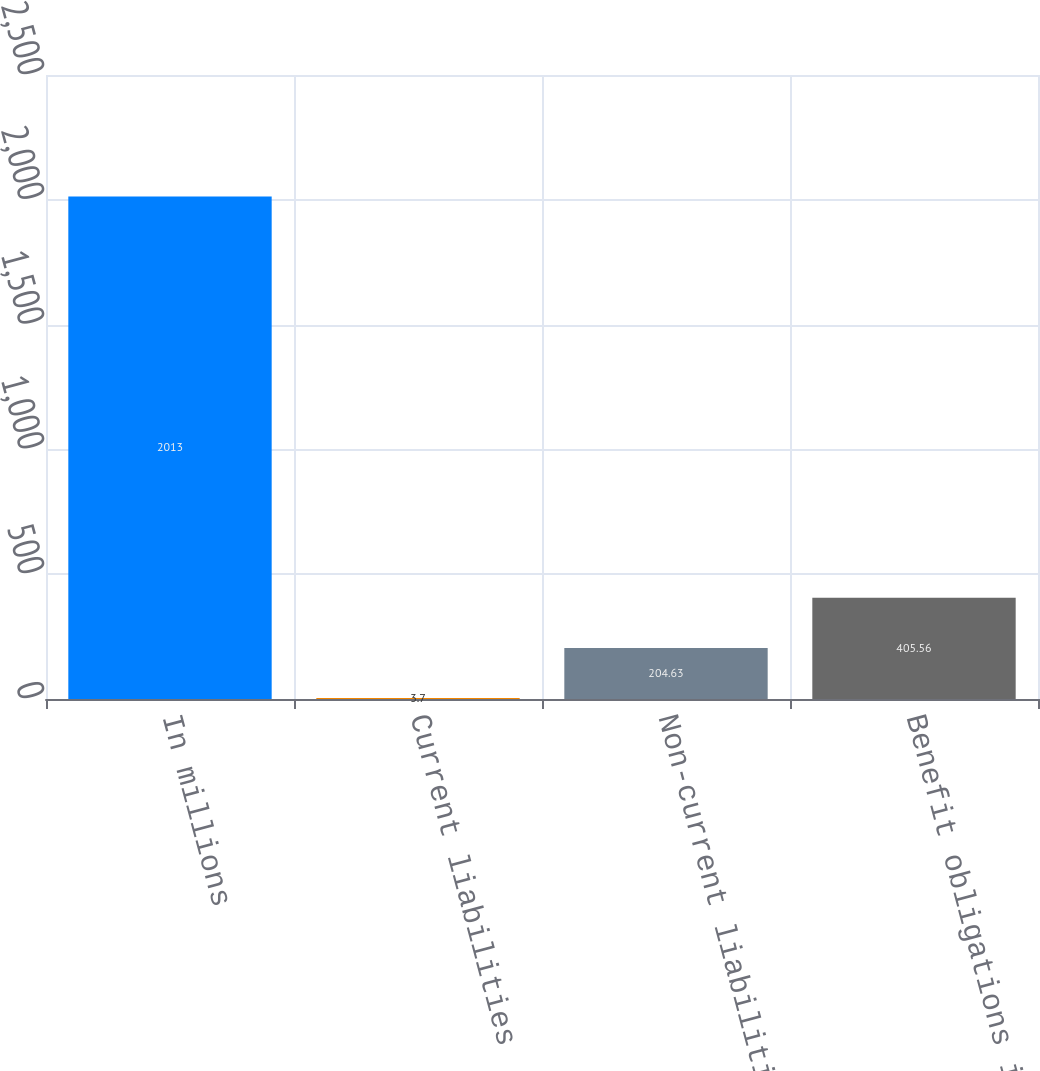Convert chart. <chart><loc_0><loc_0><loc_500><loc_500><bar_chart><fcel>In millions<fcel>Current liabilities<fcel>Non-current liabilities<fcel>Benefit obligations in excess<nl><fcel>2013<fcel>3.7<fcel>204.63<fcel>405.56<nl></chart> 